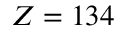<formula> <loc_0><loc_0><loc_500><loc_500>Z = 1 3 4</formula> 